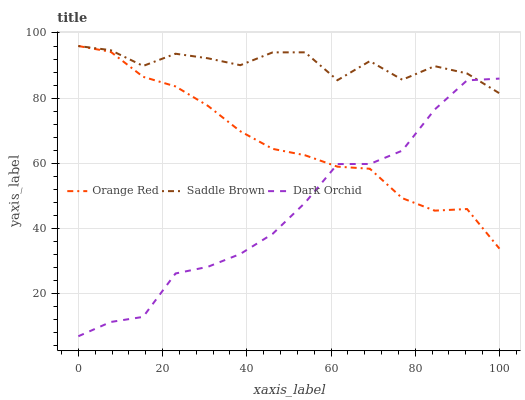Does Dark Orchid have the minimum area under the curve?
Answer yes or no. Yes. Does Saddle Brown have the maximum area under the curve?
Answer yes or no. Yes. Does Saddle Brown have the minimum area under the curve?
Answer yes or no. No. Does Dark Orchid have the maximum area under the curve?
Answer yes or no. No. Is Orange Red the smoothest?
Answer yes or no. Yes. Is Saddle Brown the roughest?
Answer yes or no. Yes. Is Dark Orchid the smoothest?
Answer yes or no. No. Is Dark Orchid the roughest?
Answer yes or no. No. Does Dark Orchid have the lowest value?
Answer yes or no. Yes. Does Saddle Brown have the lowest value?
Answer yes or no. No. Does Saddle Brown have the highest value?
Answer yes or no. Yes. Does Dark Orchid have the highest value?
Answer yes or no. No. Does Saddle Brown intersect Dark Orchid?
Answer yes or no. Yes. Is Saddle Brown less than Dark Orchid?
Answer yes or no. No. Is Saddle Brown greater than Dark Orchid?
Answer yes or no. No. 